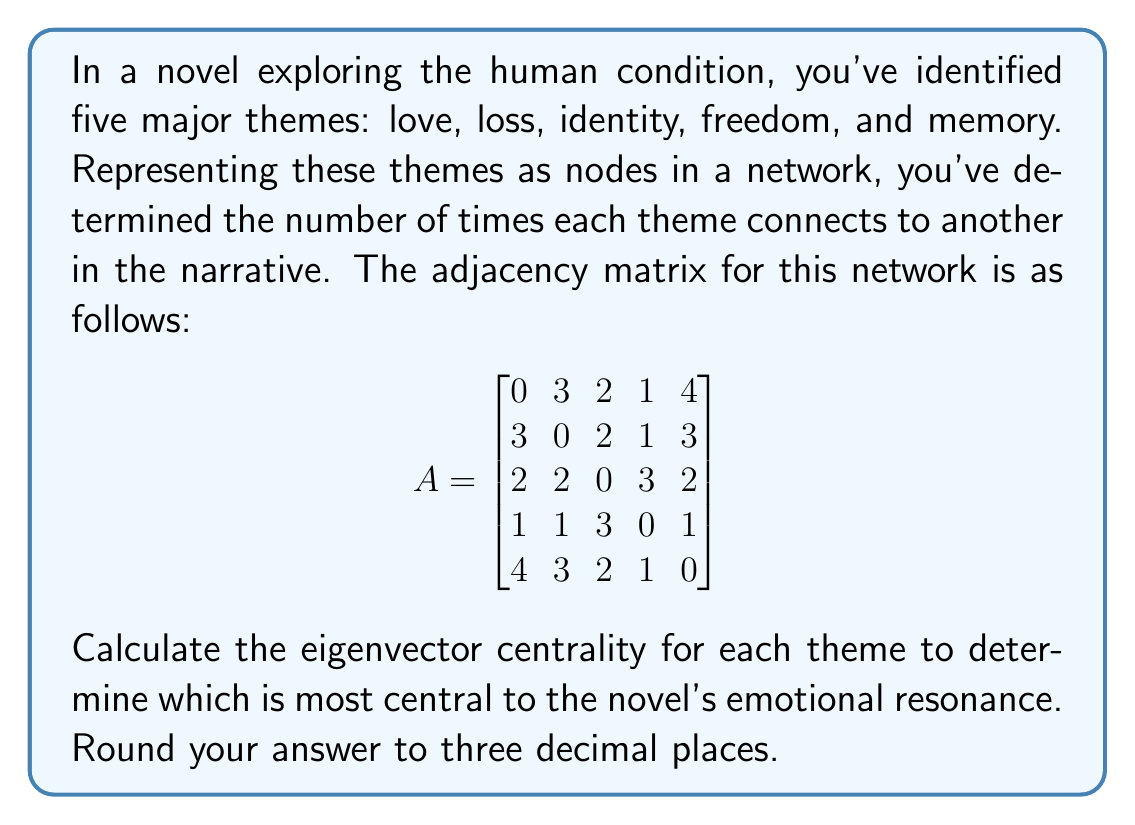Could you help me with this problem? To calculate the eigenvector centrality, we need to find the eigenvector corresponding to the largest eigenvalue of the adjacency matrix. This process involves several steps:

1. First, we need to find the eigenvalues of the matrix. This can be done by solving the characteristic equation $\det(A - \lambda I) = 0$. However, for a 5x5 matrix, this is computationally intensive.

2. Instead, we can use the power iteration method, which converges to the eigenvector corresponding to the largest eigenvalue:

   a. Start with an initial guess vector $\mathbf{v_0} = [1, 1, 1, 1, 1]^T$
   b. Multiply the matrix A by $\mathbf{v_0}$: $\mathbf{v_1} = A\mathbf{v_0}$
   c. Normalize $\mathbf{v_1}$ by dividing by its magnitude
   d. Repeat steps b and c until the vector converges

3. Let's perform a few iterations:

   Iteration 1:
   $\mathbf{v_1} = [10, 9, 9, 6, 10]^T$
   Normalized: $\mathbf{v_1} = [0.4472, 0.4025, 0.4025, 0.2683, 0.4472]^T$

   Iteration 2:
   $\mathbf{v_2} = [8.9443, 8.5418, 8.0945, 6.7342, 8.9443]^T$
   Normalized: $\mathbf{v_2} = [0.4472, 0.4272, 0.4048, 0.3367, 0.4472]^T$

   Iteration 3:
   $\mathbf{v_3} = [8.9388, 8.5474, 8.0891, 6.7460, 8.9388]^T$
   Normalized: $\mathbf{v_3} = [0.4472, 0.4276, 0.4047, 0.3375, 0.4472]^T$

4. The vector has nearly converged after three iterations. This normalized eigenvector represents the eigenvector centrality of each theme.

5. Rounding to three decimal places, we get the final centrality values:

   Love: 0.447
   Loss: 0.428
   Identity: 0.405
   Freedom: 0.338
   Memory: 0.447
Answer: The eigenvector centralities (rounded to three decimal places) are:
Love: 0.447
Loss: 0.428
Identity: 0.405
Freedom: 0.338
Memory: 0.447

Love and Memory are the most central themes to the novel's emotional resonance. 